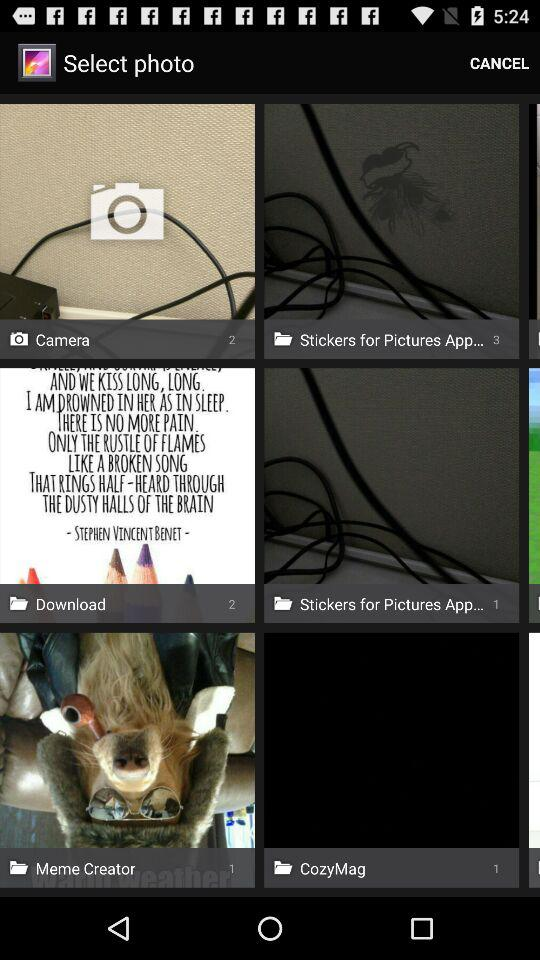What is the number of photos in "Download"? The number of photos in "Download" is 2. 